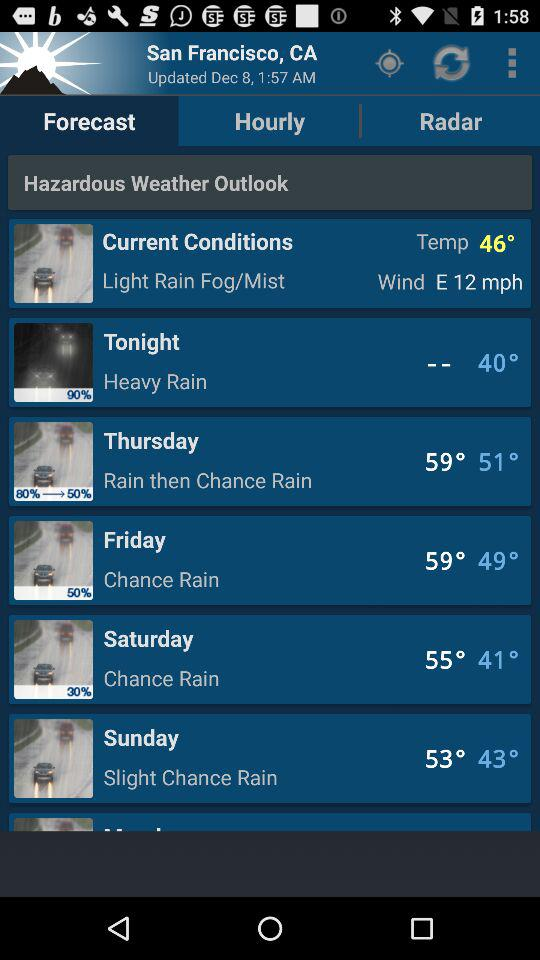What is the temperature tonight? Tonight's temperature is 40°. 